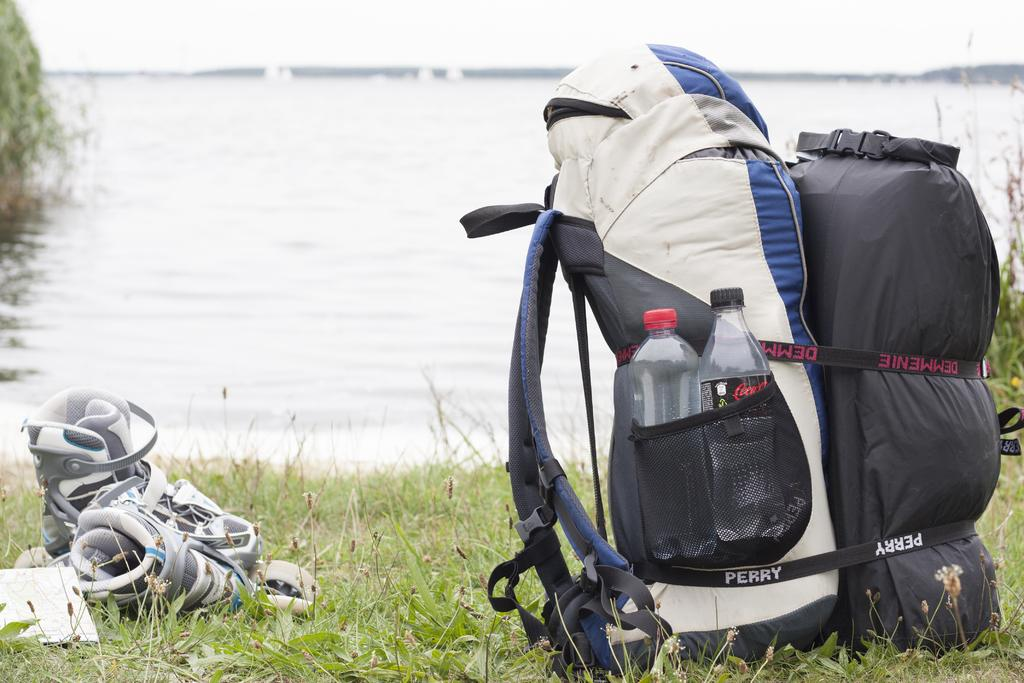<image>
Relay a brief, clear account of the picture shown. The two straps on a backpack and sleeping bag read Perry and Demmenie. 